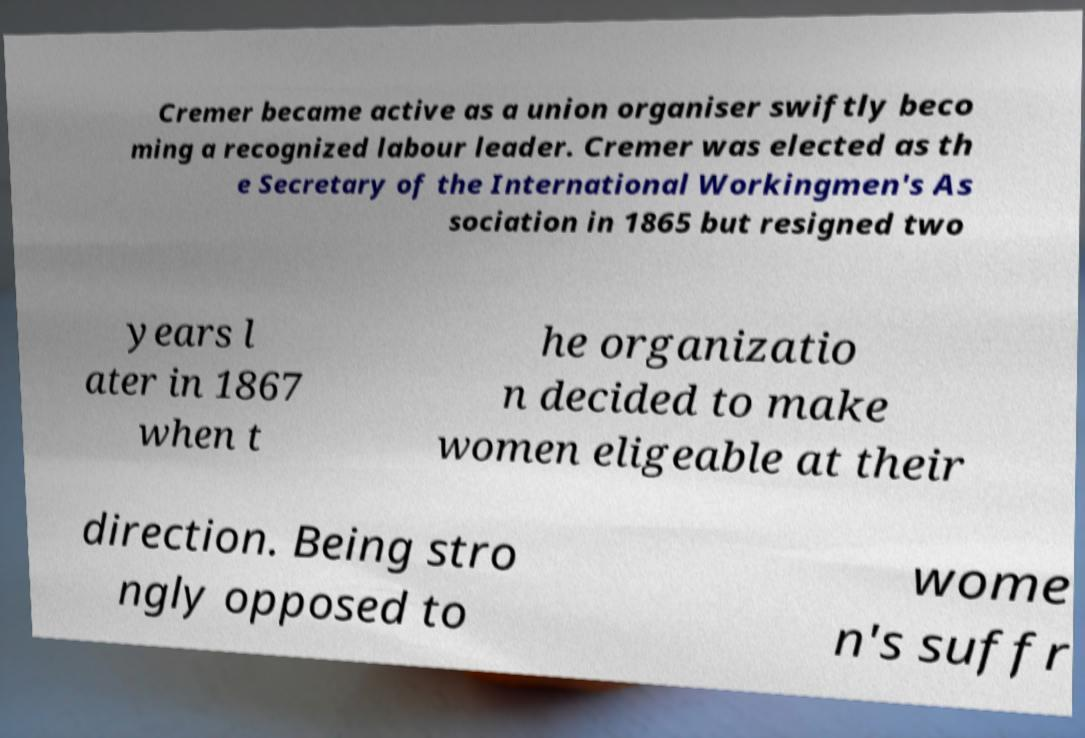What messages or text are displayed in this image? I need them in a readable, typed format. Cremer became active as a union organiser swiftly beco ming a recognized labour leader. Cremer was elected as th e Secretary of the International Workingmen's As sociation in 1865 but resigned two years l ater in 1867 when t he organizatio n decided to make women eligeable at their direction. Being stro ngly opposed to wome n's suffr 